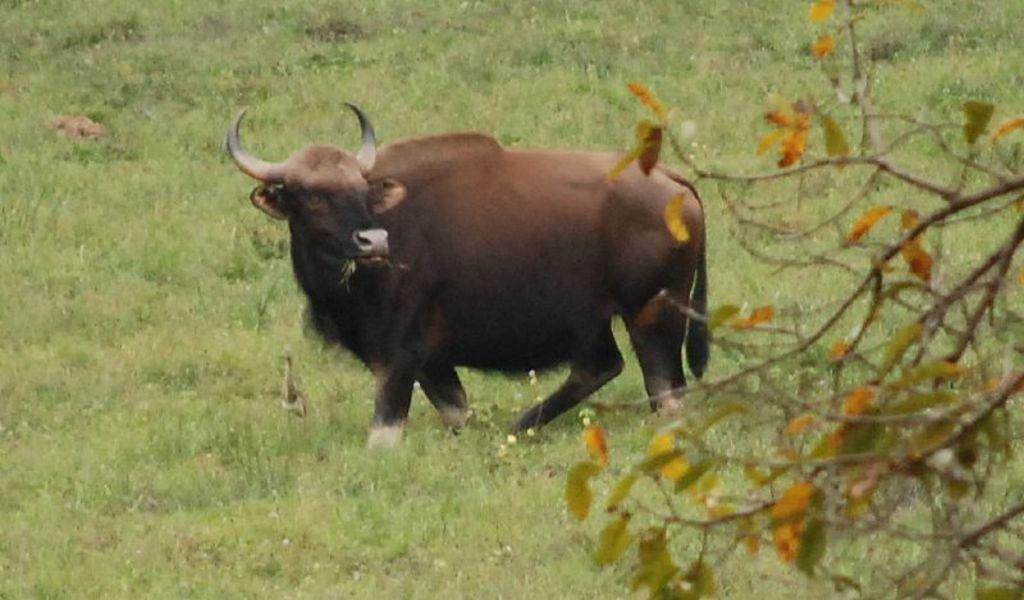Please provide a concise description of this image. In this image I can see an animal which is brown, cream and black in color is standing on the ground. I can see some grass and a tree. I can see few leaves to the tree which are orange and green in color. 